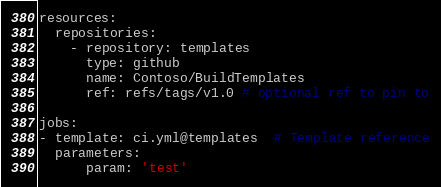<code> <loc_0><loc_0><loc_500><loc_500><_YAML_>resources:
  repositories:
    - repository: templates
      type: github
      name: Contoso/BuildTemplates
      ref: refs/tags/v1.0 # optional ref to pin to

jobs:
- template: ci.yml@templates  # Template reference
  parameters:
      param: 'test'</code> 